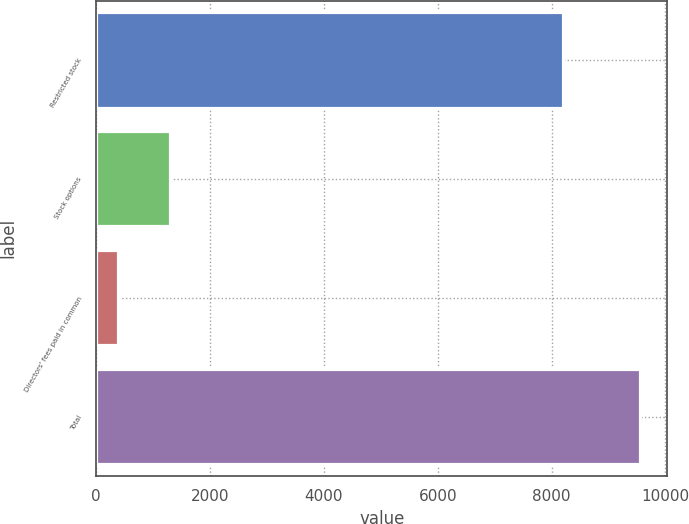<chart> <loc_0><loc_0><loc_500><loc_500><bar_chart><fcel>Restricted stock<fcel>Stock options<fcel>Directors' fees paid in common<fcel>Total<nl><fcel>8193<fcel>1293.1<fcel>375<fcel>9556<nl></chart> 